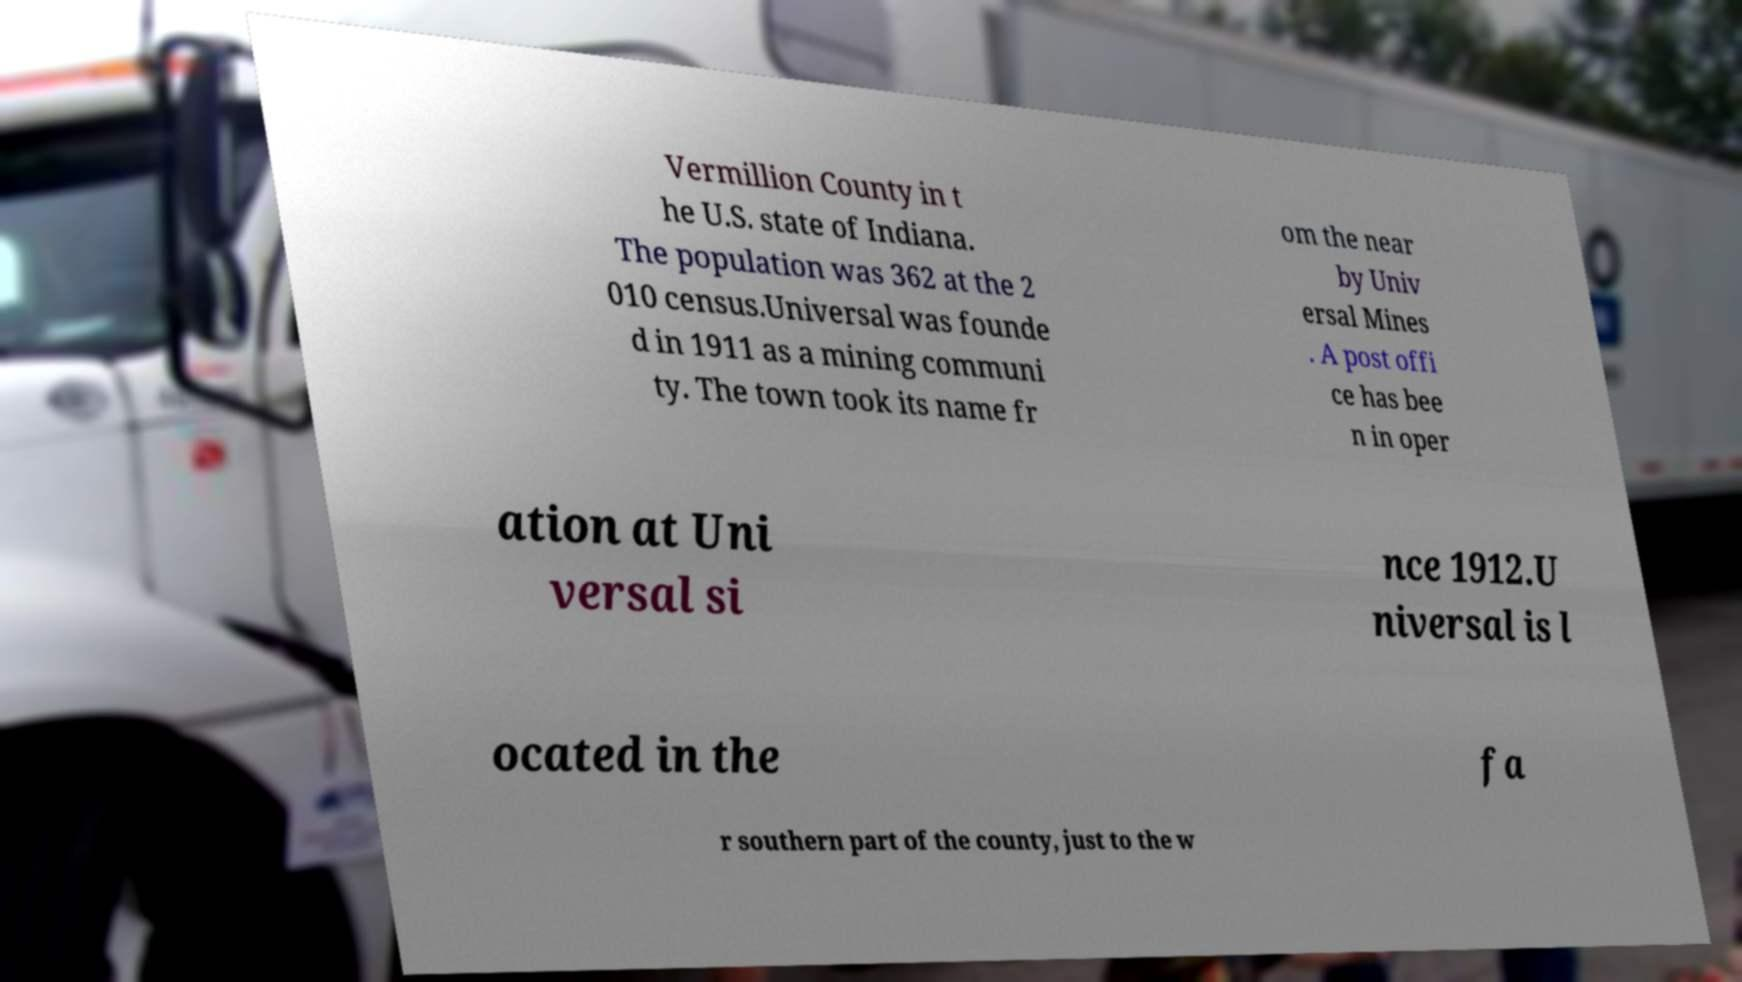Can you accurately transcribe the text from the provided image for me? Vermillion County in t he U.S. state of Indiana. The population was 362 at the 2 010 census.Universal was founde d in 1911 as a mining communi ty. The town took its name fr om the near by Univ ersal Mines . A post offi ce has bee n in oper ation at Uni versal si nce 1912.U niversal is l ocated in the fa r southern part of the county, just to the w 